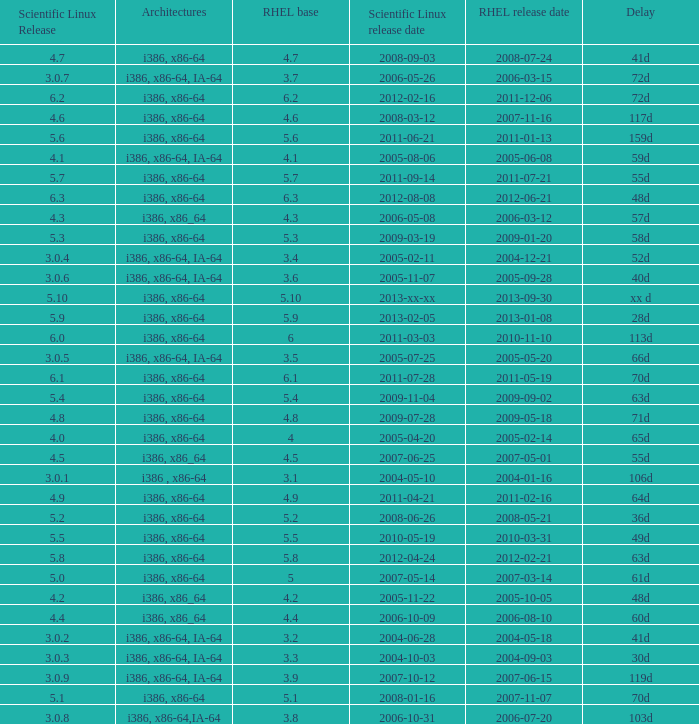Name the scientific linux release when delay is 28d 5.9. 